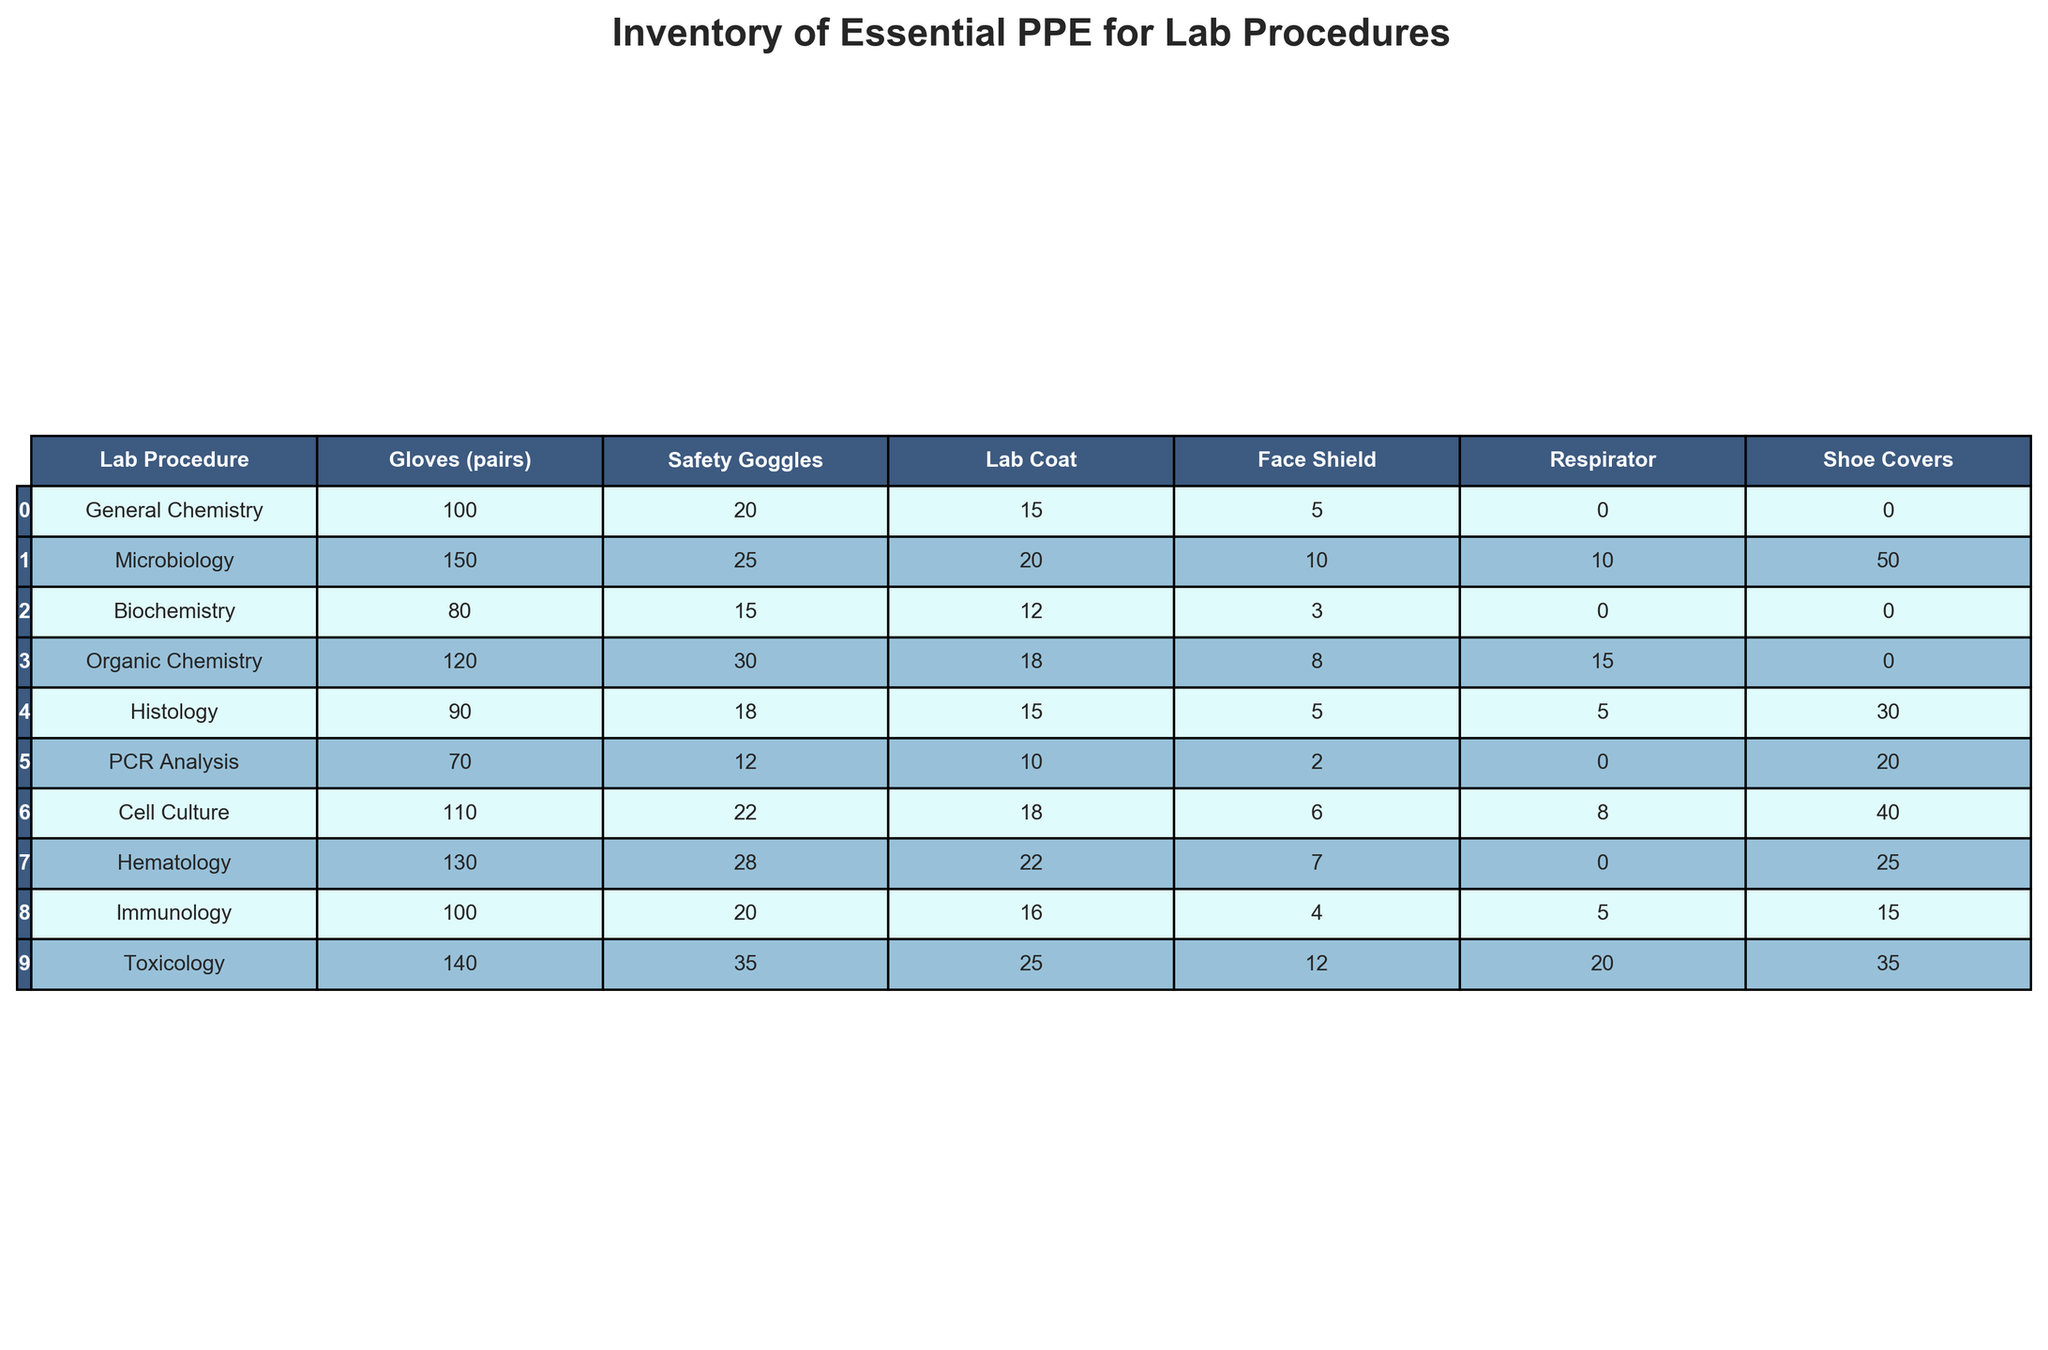What is the total number of gloves required for PCR Analysis? The table shows that for PCR Analysis, the number of gloves required is 70 pairs. Therefore, the total number of gloves required is 70.
Answer: 70 Which lab procedure requires the highest number of safety goggles? Looking at the table, Toxicology has the highest count of safety goggles needed, which is 35.
Answer: 35 How many more face shields are required for Microbiology compared to Biochemistry? The number of face shields required for Microbiology is 10 and for Biochemistry is 3. Therefore, the difference is 10 - 3 = 7.
Answer: 7 What is the average number of lab coats needed across all procedures? The total number of lab coats is 15 + 20 + 12 + 18 + 15 + 10 + 18 + 22 + 16 + 25 = 171. There are 10 procedures, so the average is 171/10 = 17.1.
Answer: 17.1 Does Histology require more shoe covers than PCR Analysis? Histology requires 30 shoe covers while PCR Analysis requires 20. Since 30 is greater than 20, the statement is true.
Answer: Yes Which lab procedure requires the least number of respirators? By examining the table, Biochemistry has 0 respirators needed, which is the least compared to all other procedures.
Answer: Biochemistry What is the total number of personal protective equipment items needed for Organic Chemistry? For Organic Chemistry, all items sum up as follows: Gloves (120) + Safety Goggles (30) + Lab Coat (18) + Face Shield (8) + Respirator (15) + Shoe Covers (0) = 291.
Answer: 291 How many lab coats are needed for Hematology and Immunology combined? The number of lab coats required for Hematology is 22 and for Immunology is 16. Combining these gives 22 + 16 = 38.
Answer: 38 Is the number of gloves for Microbiology greater than the number of gloves for Organic Chemistry? Microbiology requires 150 gloves while Organic Chemistry requires 120. Since 150 is greater than 120, the answer is yes.
Answer: Yes Which lab procedure has the highest total requirement for PPE items? Calculating total PPE for each procedure: General Chemistry (145), Microbiology (255), Biochemistry (126), Organic Chemistry (191), Histology (116), PCR Analysis (110), Cell Culture (154), Hematology (155), Immunology (156), and Toxicology (200). Microbiology has the highest total at 255.
Answer: Microbiology 